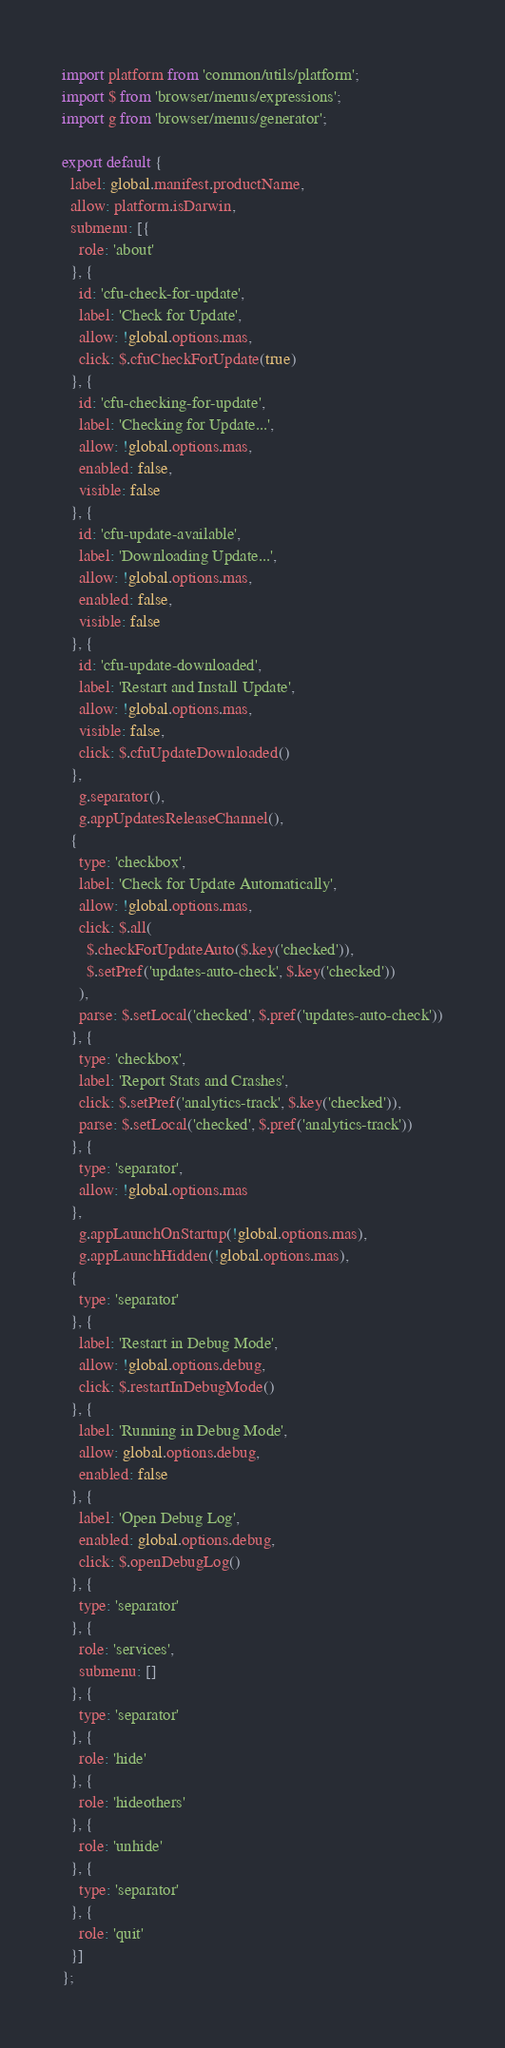<code> <loc_0><loc_0><loc_500><loc_500><_JavaScript_>import platform from 'common/utils/platform';
import $ from 'browser/menus/expressions';
import g from 'browser/menus/generator';

export default {
  label: global.manifest.productName,
  allow: platform.isDarwin,
  submenu: [{
    role: 'about'
  }, {
    id: 'cfu-check-for-update',
    label: 'Check for Update',
    allow: !global.options.mas,
    click: $.cfuCheckForUpdate(true)
  }, {
    id: 'cfu-checking-for-update',
    label: 'Checking for Update...',
    allow: !global.options.mas,
    enabled: false,
    visible: false
  }, {
    id: 'cfu-update-available',
    label: 'Downloading Update...',
    allow: !global.options.mas,
    enabled: false,
    visible: false
  }, {
    id: 'cfu-update-downloaded',
    label: 'Restart and Install Update',
    allow: !global.options.mas,
    visible: false,
    click: $.cfuUpdateDownloaded()
  },
    g.separator(),
    g.appUpdatesReleaseChannel(),
  {
    type: 'checkbox',
    label: 'Check for Update Automatically',
    allow: !global.options.mas,
    click: $.all(
      $.checkForUpdateAuto($.key('checked')),
      $.setPref('updates-auto-check', $.key('checked'))
    ),
    parse: $.setLocal('checked', $.pref('updates-auto-check'))
  }, {
    type: 'checkbox',
    label: 'Report Stats and Crashes',
    click: $.setPref('analytics-track', $.key('checked')),
    parse: $.setLocal('checked', $.pref('analytics-track'))
  }, {
    type: 'separator',
    allow: !global.options.mas
  },
    g.appLaunchOnStartup(!global.options.mas),
    g.appLaunchHidden(!global.options.mas),
  {
    type: 'separator'
  }, {
    label: 'Restart in Debug Mode',
    allow: !global.options.debug,
    click: $.restartInDebugMode()
  }, {
    label: 'Running in Debug Mode',
    allow: global.options.debug,
    enabled: false
  }, {
    label: 'Open Debug Log',
    enabled: global.options.debug,
    click: $.openDebugLog()
  }, {
    type: 'separator'
  }, {
    role: 'services',
    submenu: []
  }, {
    type: 'separator'
  }, {
    role: 'hide'
  }, {
    role: 'hideothers'
  }, {
    role: 'unhide'
  }, {
    type: 'separator'
  }, {
    role: 'quit'
  }]
};
</code> 